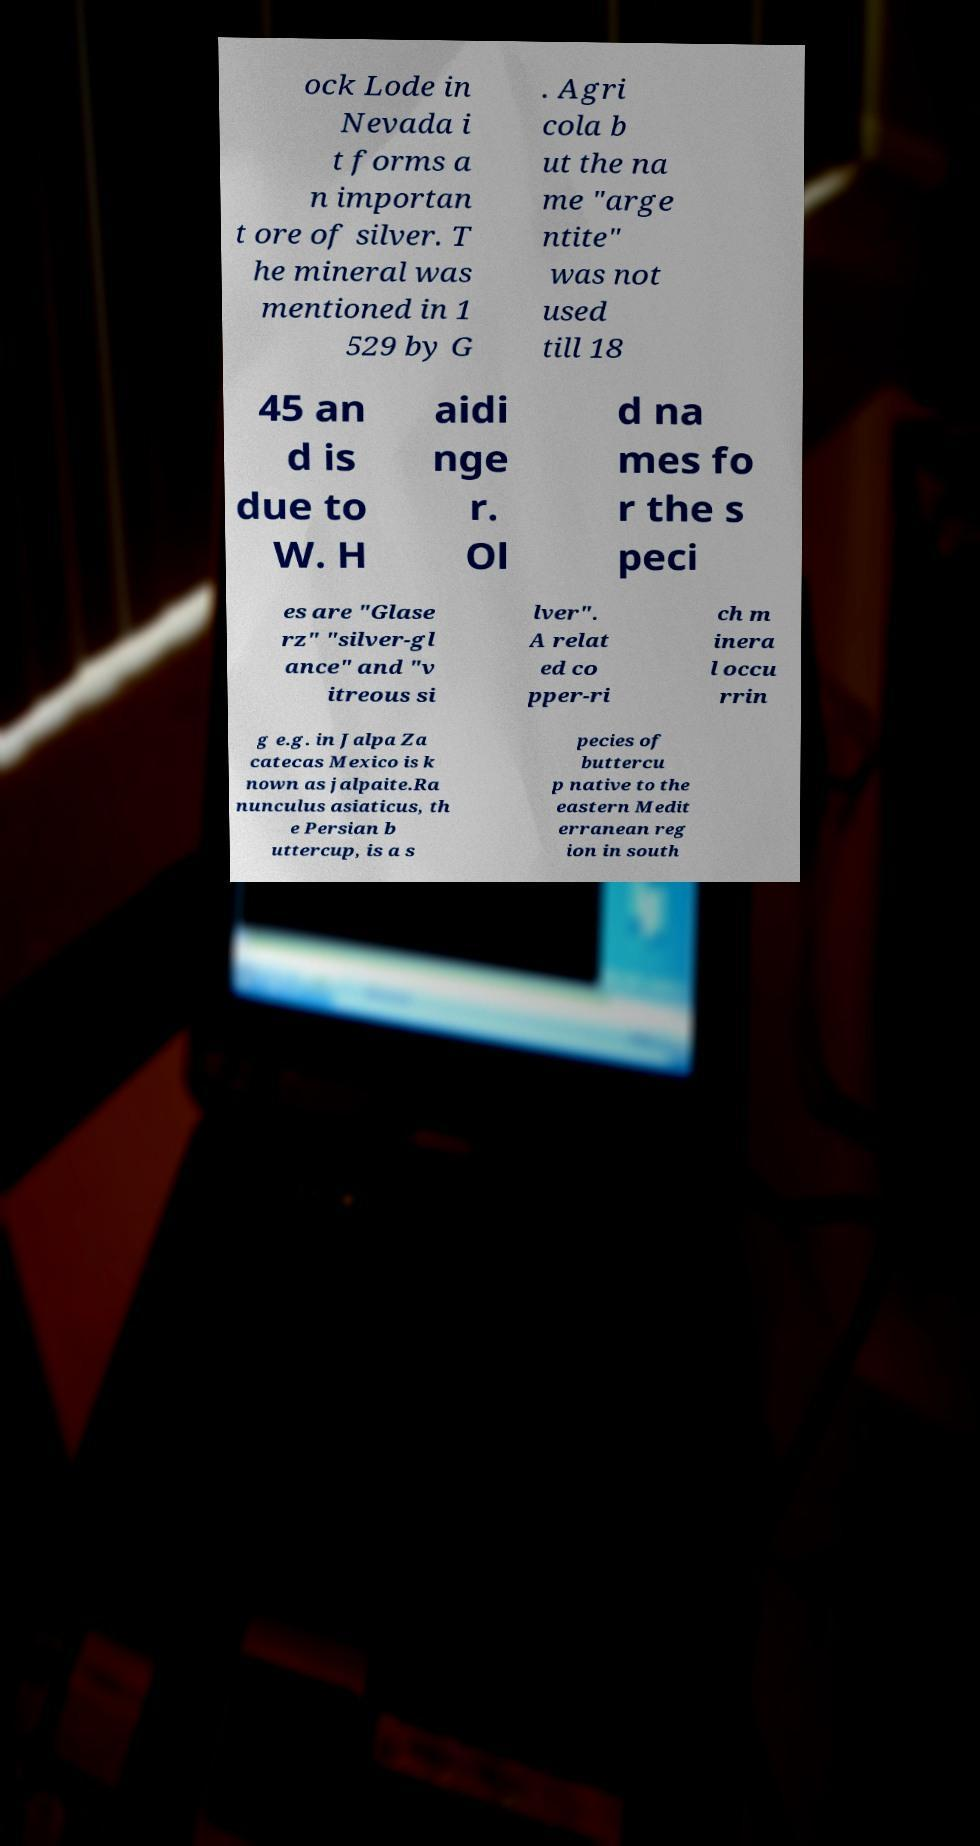Please read and relay the text visible in this image. What does it say? ock Lode in Nevada i t forms a n importan t ore of silver. T he mineral was mentioned in 1 529 by G . Agri cola b ut the na me "arge ntite" was not used till 18 45 an d is due to W. H aidi nge r. Ol d na mes fo r the s peci es are "Glase rz" "silver-gl ance" and "v itreous si lver". A relat ed co pper-ri ch m inera l occu rrin g e.g. in Jalpa Za catecas Mexico is k nown as jalpaite.Ra nunculus asiaticus, th e Persian b uttercup, is a s pecies of buttercu p native to the eastern Medit erranean reg ion in south 